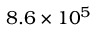Convert formula to latex. <formula><loc_0><loc_0><loc_500><loc_500>8 . 6 \times 1 0 ^ { 5 }</formula> 